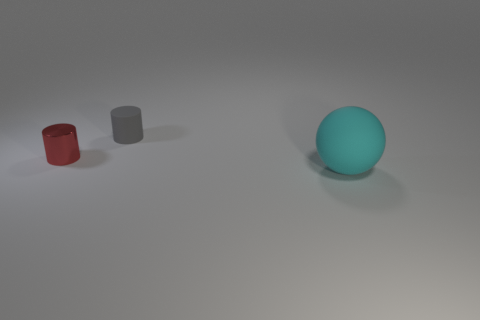There is a small cylinder left of the tiny cylinder right of the tiny metallic cylinder; what color is it?
Provide a short and direct response. Red. Is the size of the red object the same as the gray cylinder?
Your response must be concise. Yes. What number of blocks are either big things or red metallic things?
Keep it short and to the point. 0. There is a large ball in front of the tiny gray rubber cylinder; how many red cylinders are left of it?
Your answer should be compact. 1. Does the big matte thing have the same shape as the small gray object?
Provide a succinct answer. No. What is the size of the other shiny object that is the same shape as the gray thing?
Keep it short and to the point. Small. The object to the right of the matte thing that is to the left of the cyan object is what shape?
Make the answer very short. Sphere. What is the size of the gray cylinder?
Offer a terse response. Small. What shape is the big cyan matte thing?
Your answer should be compact. Sphere. Is the shape of the big cyan object the same as the tiny thing on the left side of the gray rubber object?
Offer a very short reply. No. 